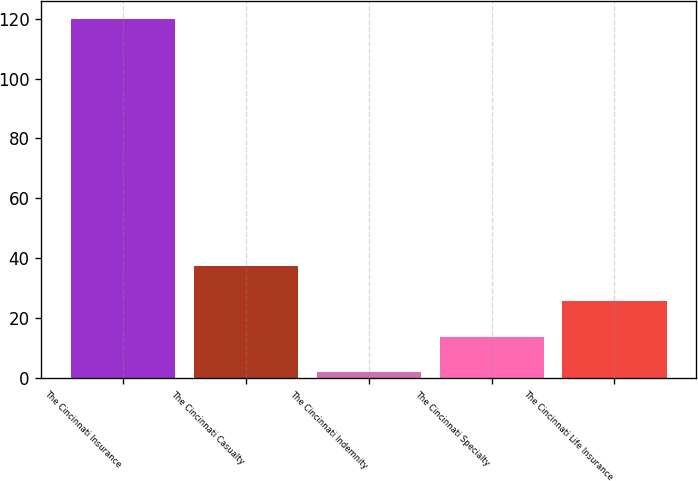Convert chart. <chart><loc_0><loc_0><loc_500><loc_500><bar_chart><fcel>The Cincinnati Insurance<fcel>The Cincinnati Casualty<fcel>The Cincinnati Indemnity<fcel>The Cincinnati Specialty<fcel>The Cincinnati Life Insurance<nl><fcel>120<fcel>37.4<fcel>2<fcel>13.8<fcel>25.6<nl></chart> 